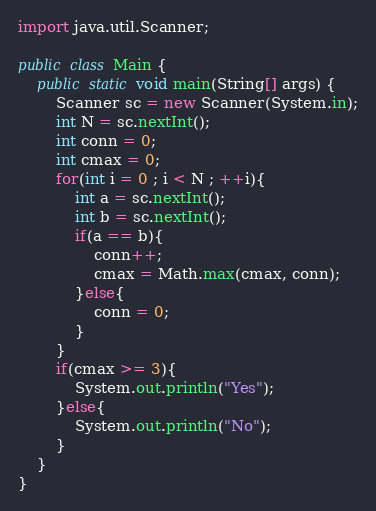Convert code to text. <code><loc_0><loc_0><loc_500><loc_500><_Java_>import java.util.Scanner;

public class Main {
	public static void main(String[] args) {
		Scanner sc = new Scanner(System.in);
		int N = sc.nextInt();
		int conn = 0;
		int cmax = 0;
		for(int i = 0 ; i < N ; ++i){
			int a = sc.nextInt();
			int b = sc.nextInt();
			if(a == b){
				conn++;
				cmax = Math.max(cmax, conn);
			}else{
				conn = 0;
			}
		}
		if(cmax >= 3){
			System.out.println("Yes");
		}else{
			System.out.println("No");			
		}
	}
}
</code> 